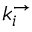Convert formula to latex. <formula><loc_0><loc_0><loc_500><loc_500>k _ { i } ^ { \rightarrow }</formula> 